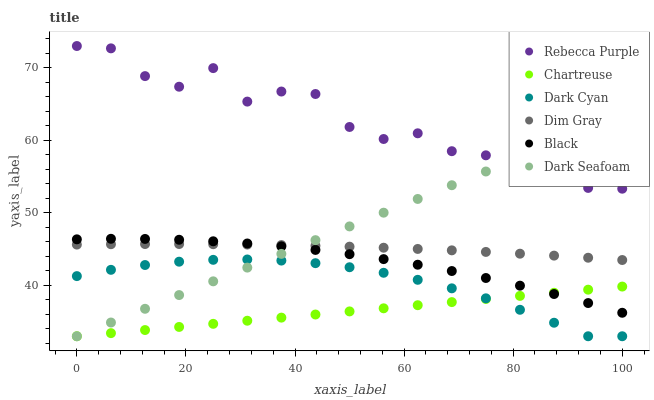Does Chartreuse have the minimum area under the curve?
Answer yes or no. Yes. Does Rebecca Purple have the maximum area under the curve?
Answer yes or no. Yes. Does Dark Seafoam have the minimum area under the curve?
Answer yes or no. No. Does Dark Seafoam have the maximum area under the curve?
Answer yes or no. No. Is Chartreuse the smoothest?
Answer yes or no. Yes. Is Rebecca Purple the roughest?
Answer yes or no. Yes. Is Dark Seafoam the smoothest?
Answer yes or no. No. Is Dark Seafoam the roughest?
Answer yes or no. No. Does Dark Seafoam have the lowest value?
Answer yes or no. Yes. Does Black have the lowest value?
Answer yes or no. No. Does Rebecca Purple have the highest value?
Answer yes or no. Yes. Does Dark Seafoam have the highest value?
Answer yes or no. No. Is Dark Cyan less than Dim Gray?
Answer yes or no. Yes. Is Rebecca Purple greater than Black?
Answer yes or no. Yes. Does Rebecca Purple intersect Dark Seafoam?
Answer yes or no. Yes. Is Rebecca Purple less than Dark Seafoam?
Answer yes or no. No. Is Rebecca Purple greater than Dark Seafoam?
Answer yes or no. No. Does Dark Cyan intersect Dim Gray?
Answer yes or no. No. 